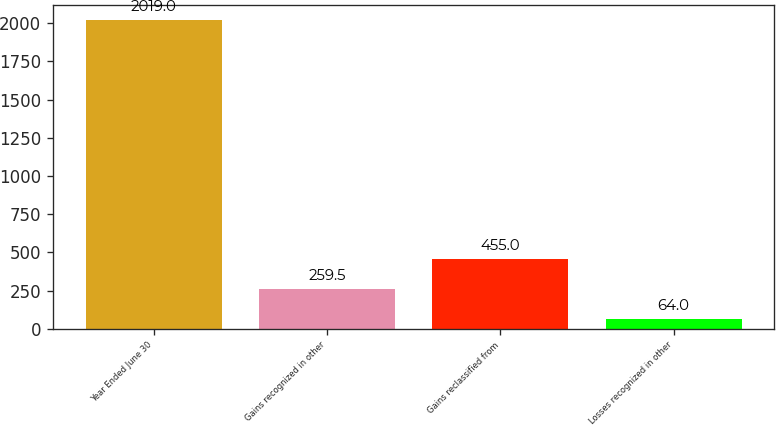Convert chart to OTSL. <chart><loc_0><loc_0><loc_500><loc_500><bar_chart><fcel>Year Ended June 30<fcel>Gains recognized in other<fcel>Gains reclassified from<fcel>Losses recognized in other<nl><fcel>2019<fcel>259.5<fcel>455<fcel>64<nl></chart> 